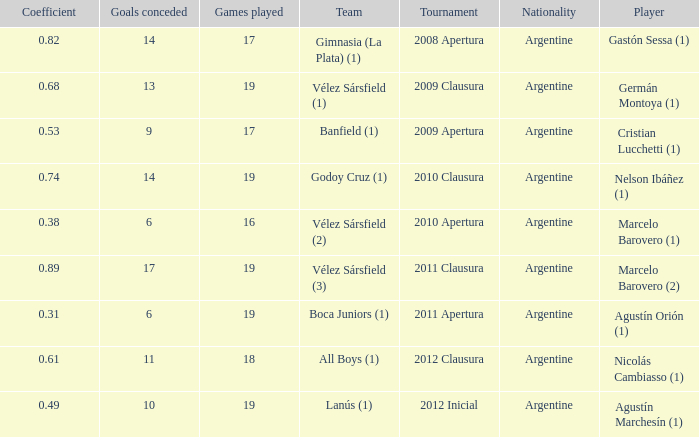What is the nationality of the 2012 clausura  tournament? Argentine. 